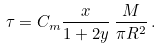<formula> <loc_0><loc_0><loc_500><loc_500>\tau = C _ { m } \frac { x } { 1 + 2 y } \, \frac { M } { \pi R ^ { 2 } } \, .</formula> 